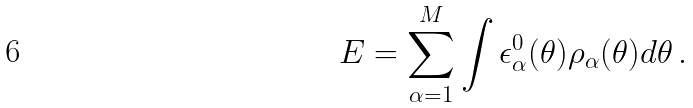<formula> <loc_0><loc_0><loc_500><loc_500>E = \sum _ { \alpha = 1 } ^ { M } \int \epsilon _ { \alpha } ^ { 0 } ( \theta ) \rho _ { \alpha } ( \theta ) d \theta \, .</formula> 